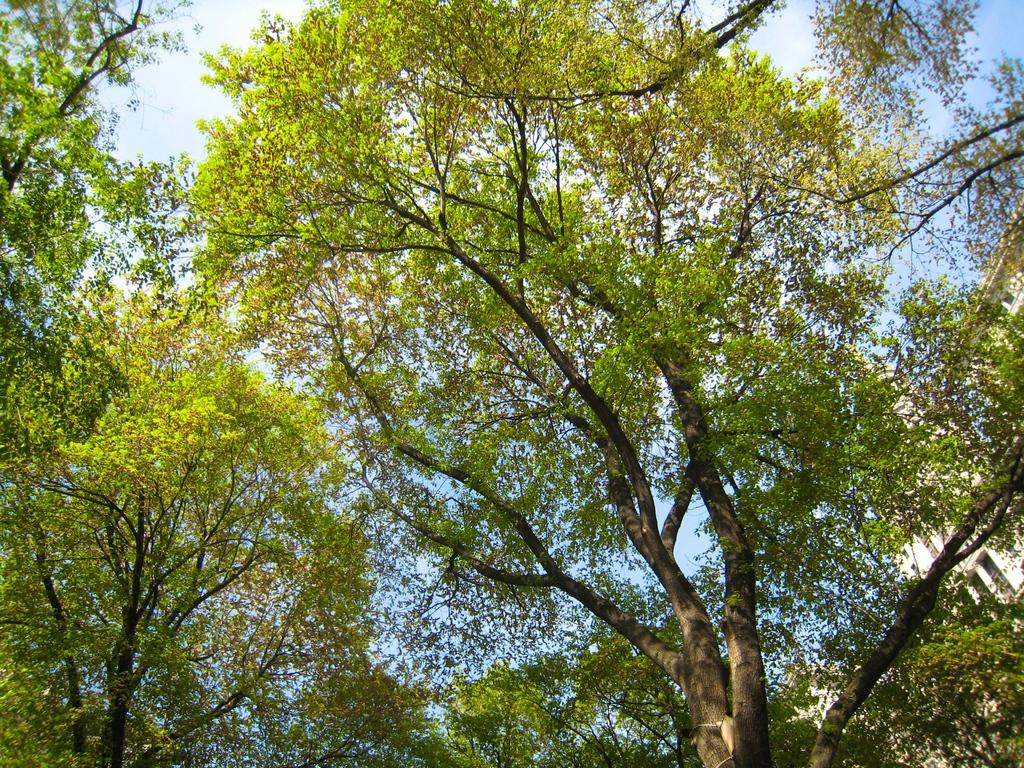What type of vegetation can be seen in the image? There are trees in the image. What is visible at the top of the image? The sky is visible at the top of the image. Where are the scissors located in the image? There are no scissors present in the image. What color is the thing in the stomach of the person in the image? There is no person or stomach present in the image; it only features trees and the sky. 